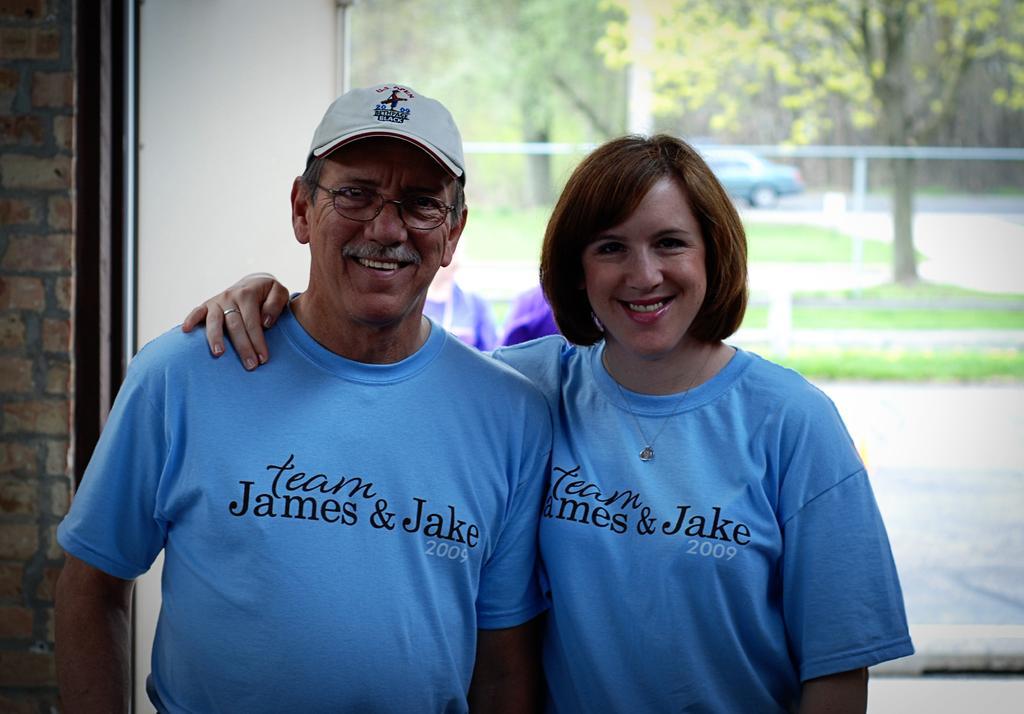How would you summarize this image in a sentence or two? This image is taken indoors. In the background there is a wall with a glass window and through the glass we can see there are a few trees and there is a ground with grass on it. A car is parked on the road. In the middle of the image a man and a woman are standing and they are with smiling faces. 